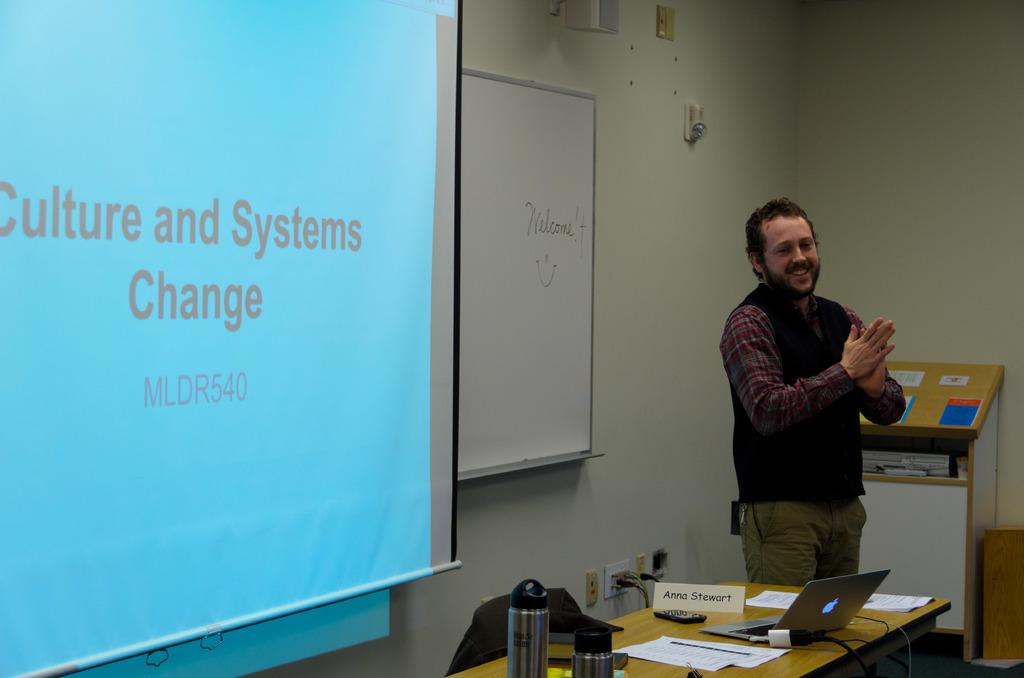<image>
Create a compact narrative representing the image presented. A man stands by a blue background reading Culture and Systems Change. 